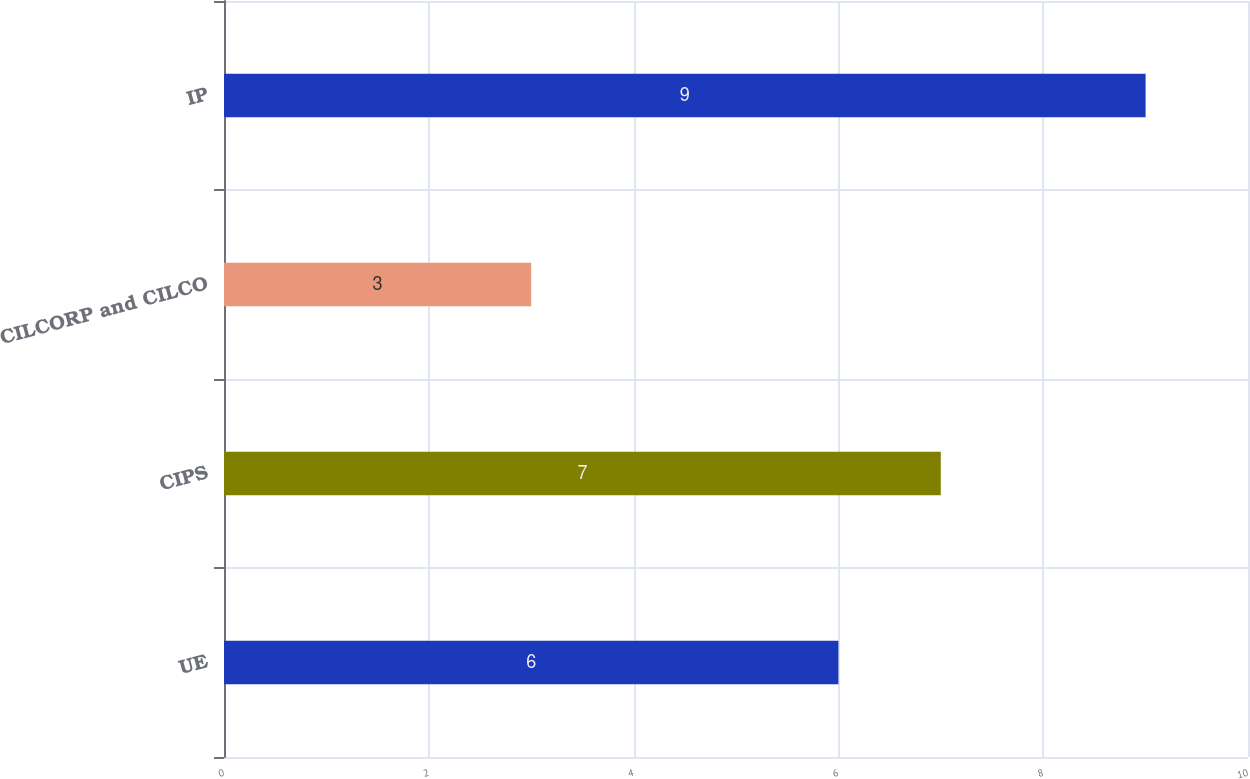Convert chart. <chart><loc_0><loc_0><loc_500><loc_500><bar_chart><fcel>UE<fcel>CIPS<fcel>CILCORP and CILCO<fcel>IP<nl><fcel>6<fcel>7<fcel>3<fcel>9<nl></chart> 